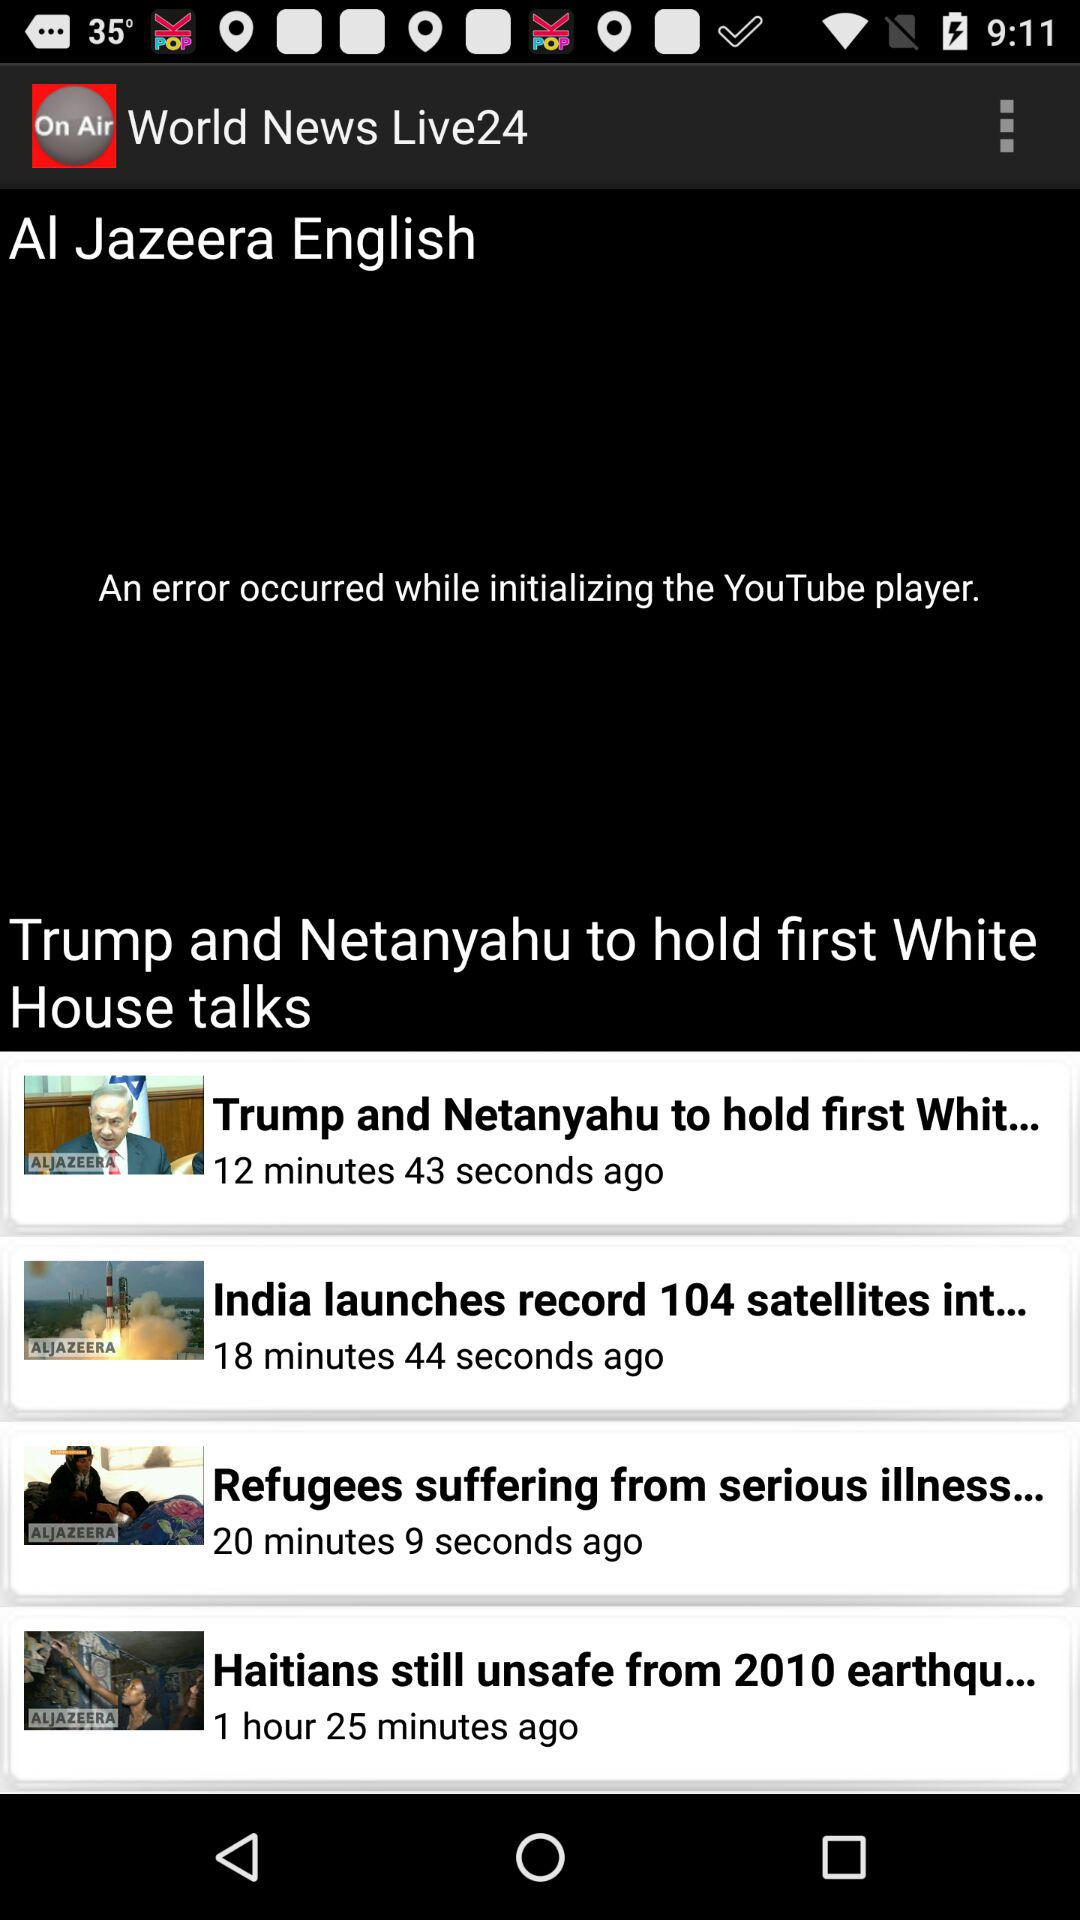What is the name of the application? The name of the application is "World News Live24". 